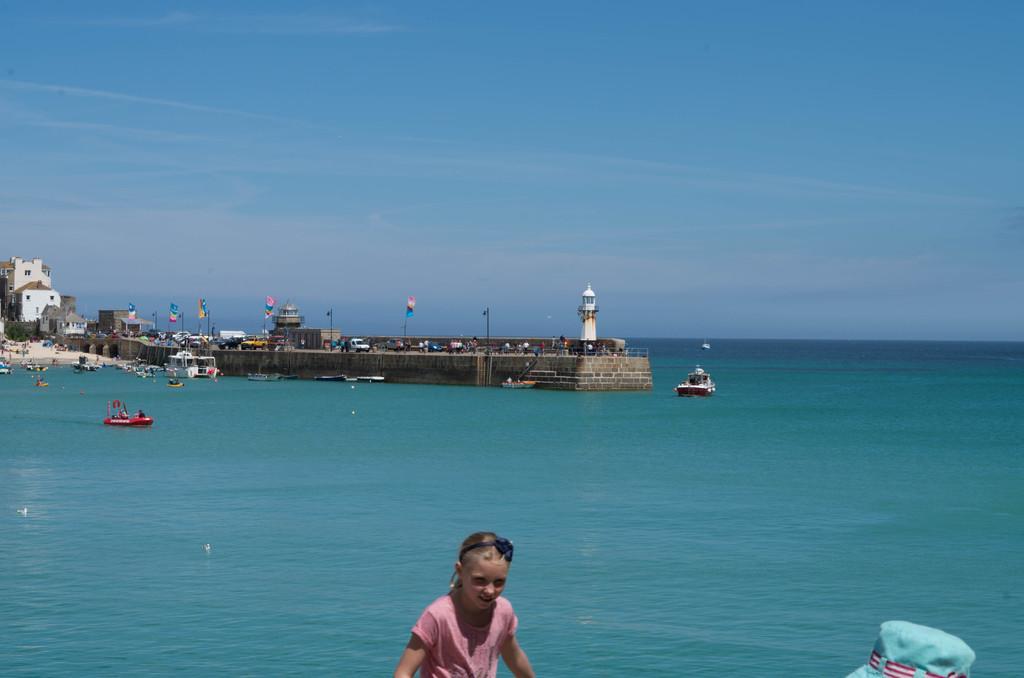Describe this image in one or two sentences. In this image it seems like it is an ocean. There is a girl in the middle. In the background there is a bridge on which there are vehicles and flags beside it. On the left side there are buildings near the shore. In the ocean there are so many boats. On the bridge there are so many people walking on it. At the top there is sky. 